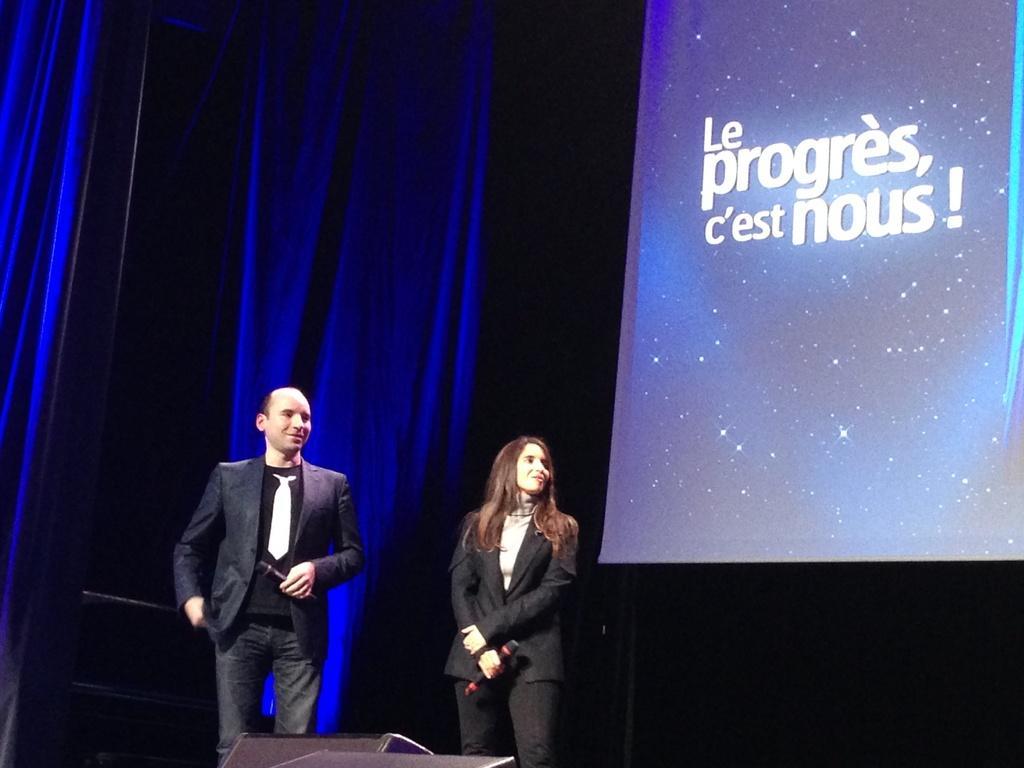Could you give a brief overview of what you see in this image? In this picture we can see a man and a woman wore blazers and holding mics with their hands and smiling and standing and in front of them we can see some objects and in the background we can see curtains and a screen with some text on it. 